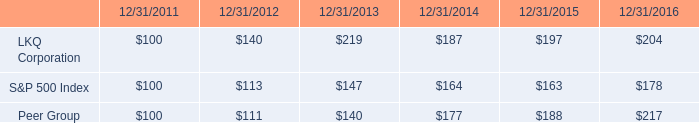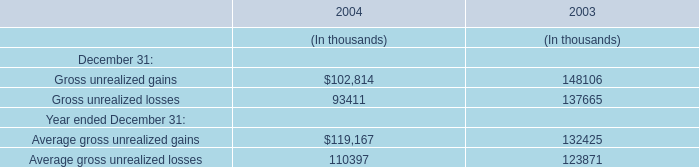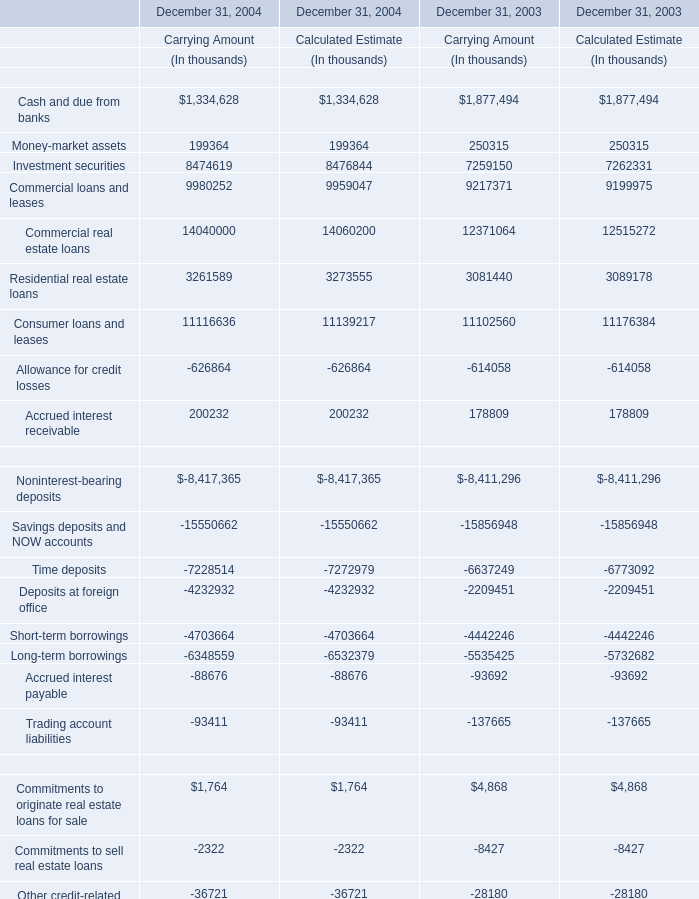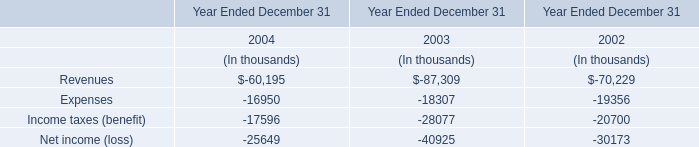What's the current growth rate of Investment securities in carrying amount? (in %) 
Computations: ((8474619 - 7259150) / 7259150)
Answer: 0.16744. 